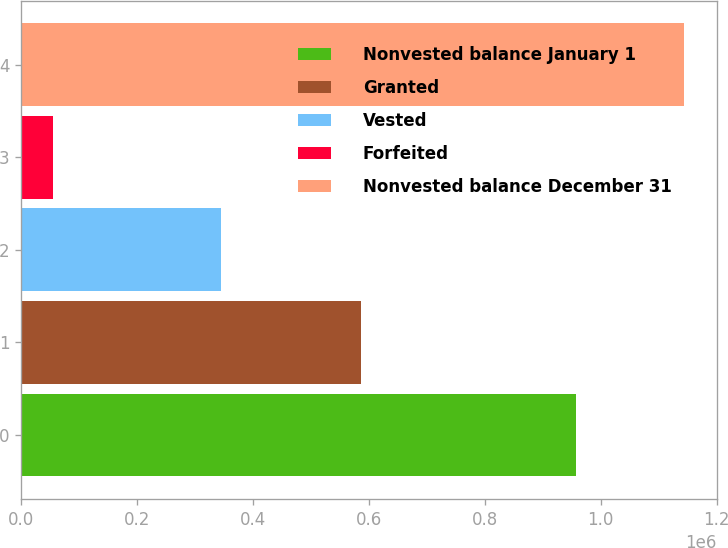Convert chart to OTSL. <chart><loc_0><loc_0><loc_500><loc_500><bar_chart><fcel>Nonvested balance January 1<fcel>Granted<fcel>Vested<fcel>Forfeited<fcel>Nonvested balance December 31<nl><fcel>956697<fcel>586695<fcel>345695<fcel>54415<fcel>1.14328e+06<nl></chart> 